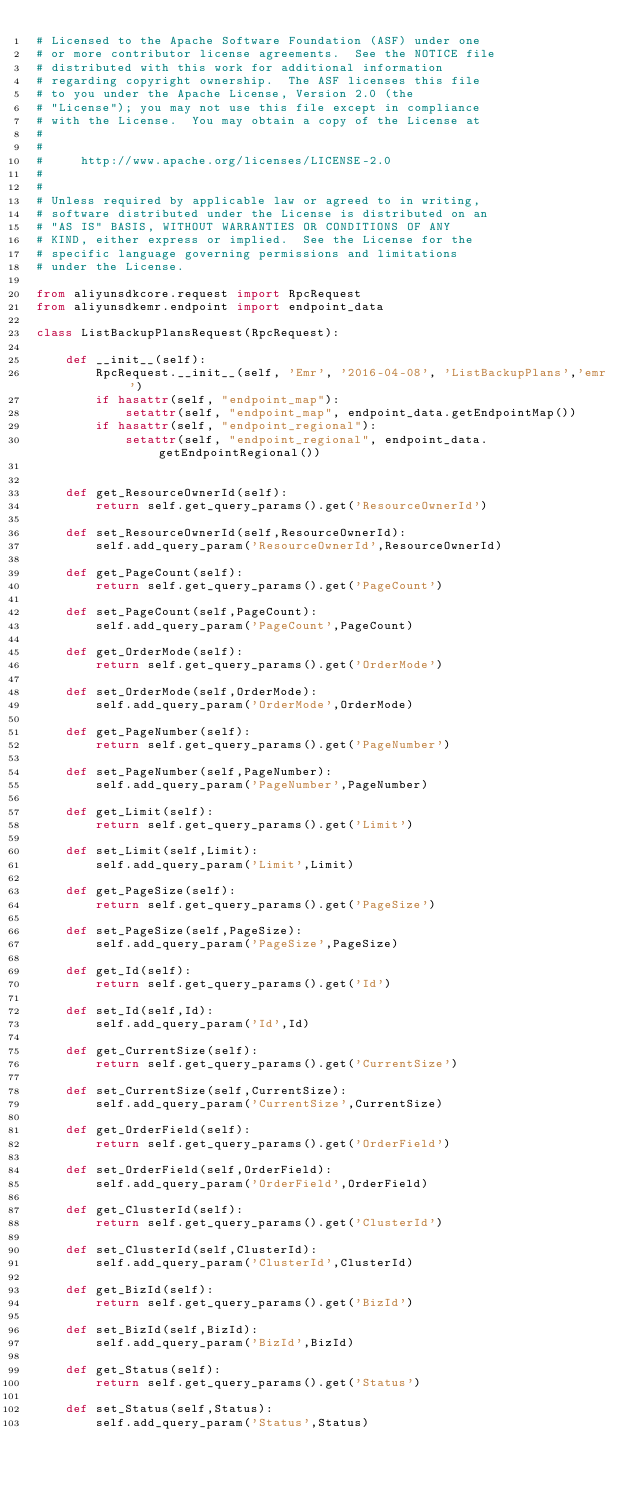<code> <loc_0><loc_0><loc_500><loc_500><_Python_># Licensed to the Apache Software Foundation (ASF) under one
# or more contributor license agreements.  See the NOTICE file
# distributed with this work for additional information
# regarding copyright ownership.  The ASF licenses this file
# to you under the Apache License, Version 2.0 (the
# "License"); you may not use this file except in compliance
# with the License.  You may obtain a copy of the License at
#
#
#     http://www.apache.org/licenses/LICENSE-2.0
#
#
# Unless required by applicable law or agreed to in writing,
# software distributed under the License is distributed on an
# "AS IS" BASIS, WITHOUT WARRANTIES OR CONDITIONS OF ANY
# KIND, either express or implied.  See the License for the
# specific language governing permissions and limitations
# under the License.

from aliyunsdkcore.request import RpcRequest
from aliyunsdkemr.endpoint import endpoint_data

class ListBackupPlansRequest(RpcRequest):

	def __init__(self):
		RpcRequest.__init__(self, 'Emr', '2016-04-08', 'ListBackupPlans','emr')
		if hasattr(self, "endpoint_map"):
			setattr(self, "endpoint_map", endpoint_data.getEndpointMap())
		if hasattr(self, "endpoint_regional"):
			setattr(self, "endpoint_regional", endpoint_data.getEndpointRegional())


	def get_ResourceOwnerId(self):
		return self.get_query_params().get('ResourceOwnerId')

	def set_ResourceOwnerId(self,ResourceOwnerId):
		self.add_query_param('ResourceOwnerId',ResourceOwnerId)

	def get_PageCount(self):
		return self.get_query_params().get('PageCount')

	def set_PageCount(self,PageCount):
		self.add_query_param('PageCount',PageCount)

	def get_OrderMode(self):
		return self.get_query_params().get('OrderMode')

	def set_OrderMode(self,OrderMode):
		self.add_query_param('OrderMode',OrderMode)

	def get_PageNumber(self):
		return self.get_query_params().get('PageNumber')

	def set_PageNumber(self,PageNumber):
		self.add_query_param('PageNumber',PageNumber)

	def get_Limit(self):
		return self.get_query_params().get('Limit')

	def set_Limit(self,Limit):
		self.add_query_param('Limit',Limit)

	def get_PageSize(self):
		return self.get_query_params().get('PageSize')

	def set_PageSize(self,PageSize):
		self.add_query_param('PageSize',PageSize)

	def get_Id(self):
		return self.get_query_params().get('Id')

	def set_Id(self,Id):
		self.add_query_param('Id',Id)

	def get_CurrentSize(self):
		return self.get_query_params().get('CurrentSize')

	def set_CurrentSize(self,CurrentSize):
		self.add_query_param('CurrentSize',CurrentSize)

	def get_OrderField(self):
		return self.get_query_params().get('OrderField')

	def set_OrderField(self,OrderField):
		self.add_query_param('OrderField',OrderField)

	def get_ClusterId(self):
		return self.get_query_params().get('ClusterId')

	def set_ClusterId(self,ClusterId):
		self.add_query_param('ClusterId',ClusterId)

	def get_BizId(self):
		return self.get_query_params().get('BizId')

	def set_BizId(self,BizId):
		self.add_query_param('BizId',BizId)

	def get_Status(self):
		return self.get_query_params().get('Status')

	def set_Status(self,Status):
		self.add_query_param('Status',Status)</code> 